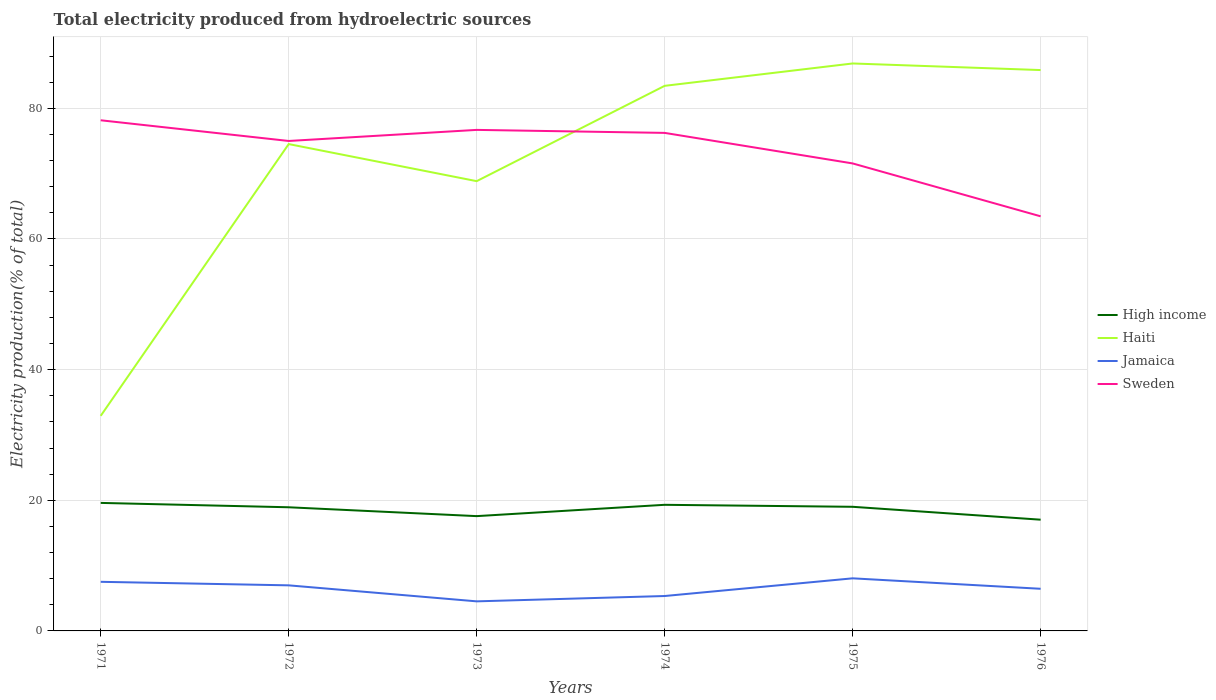How many different coloured lines are there?
Provide a succinct answer. 4. Does the line corresponding to High income intersect with the line corresponding to Jamaica?
Keep it short and to the point. No. Is the number of lines equal to the number of legend labels?
Your answer should be compact. Yes. Across all years, what is the maximum total electricity produced in Jamaica?
Offer a terse response. 4.53. In which year was the total electricity produced in High income maximum?
Ensure brevity in your answer.  1976. What is the total total electricity produced in Sweden in the graph?
Your answer should be compact. 3.44. What is the difference between the highest and the second highest total electricity produced in Sweden?
Offer a very short reply. 14.7. What is the difference between the highest and the lowest total electricity produced in Haiti?
Give a very brief answer. 4. How many years are there in the graph?
Give a very brief answer. 6. Does the graph contain any zero values?
Your answer should be compact. No. Where does the legend appear in the graph?
Make the answer very short. Center right. What is the title of the graph?
Keep it short and to the point. Total electricity produced from hydroelectric sources. Does "Middle income" appear as one of the legend labels in the graph?
Make the answer very short. No. What is the label or title of the Y-axis?
Ensure brevity in your answer.  Electricity production(% of total). What is the Electricity production(% of total) of High income in 1971?
Give a very brief answer. 19.6. What is the Electricity production(% of total) of Haiti in 1971?
Your answer should be compact. 32.93. What is the Electricity production(% of total) of Jamaica in 1971?
Keep it short and to the point. 7.52. What is the Electricity production(% of total) in Sweden in 1971?
Your response must be concise. 78.17. What is the Electricity production(% of total) of High income in 1972?
Ensure brevity in your answer.  18.93. What is the Electricity production(% of total) in Haiti in 1972?
Provide a short and direct response. 74.53. What is the Electricity production(% of total) in Jamaica in 1972?
Your answer should be compact. 6.98. What is the Electricity production(% of total) in Sweden in 1972?
Your answer should be very brief. 75. What is the Electricity production(% of total) in High income in 1973?
Offer a terse response. 17.57. What is the Electricity production(% of total) of Haiti in 1973?
Ensure brevity in your answer.  68.85. What is the Electricity production(% of total) of Jamaica in 1973?
Your answer should be compact. 4.53. What is the Electricity production(% of total) of Sweden in 1973?
Keep it short and to the point. 76.7. What is the Electricity production(% of total) of High income in 1974?
Provide a succinct answer. 19.31. What is the Electricity production(% of total) of Haiti in 1974?
Provide a short and direct response. 83.44. What is the Electricity production(% of total) in Jamaica in 1974?
Give a very brief answer. 5.34. What is the Electricity production(% of total) of Sweden in 1974?
Keep it short and to the point. 76.24. What is the Electricity production(% of total) in High income in 1975?
Keep it short and to the point. 19. What is the Electricity production(% of total) in Haiti in 1975?
Your answer should be compact. 86.87. What is the Electricity production(% of total) in Jamaica in 1975?
Offer a very short reply. 8.05. What is the Electricity production(% of total) in Sweden in 1975?
Your response must be concise. 71.57. What is the Electricity production(% of total) of High income in 1976?
Provide a succinct answer. 17.03. What is the Electricity production(% of total) in Haiti in 1976?
Make the answer very short. 85.86. What is the Electricity production(% of total) in Jamaica in 1976?
Provide a short and direct response. 6.45. What is the Electricity production(% of total) in Sweden in 1976?
Make the answer very short. 63.47. Across all years, what is the maximum Electricity production(% of total) of High income?
Make the answer very short. 19.6. Across all years, what is the maximum Electricity production(% of total) in Haiti?
Offer a terse response. 86.87. Across all years, what is the maximum Electricity production(% of total) in Jamaica?
Make the answer very short. 8.05. Across all years, what is the maximum Electricity production(% of total) in Sweden?
Your answer should be compact. 78.17. Across all years, what is the minimum Electricity production(% of total) in High income?
Your response must be concise. 17.03. Across all years, what is the minimum Electricity production(% of total) in Haiti?
Your answer should be very brief. 32.93. Across all years, what is the minimum Electricity production(% of total) of Jamaica?
Keep it short and to the point. 4.53. Across all years, what is the minimum Electricity production(% of total) in Sweden?
Your response must be concise. 63.47. What is the total Electricity production(% of total) in High income in the graph?
Your answer should be compact. 111.44. What is the total Electricity production(% of total) in Haiti in the graph?
Offer a very short reply. 432.48. What is the total Electricity production(% of total) of Jamaica in the graph?
Keep it short and to the point. 38.87. What is the total Electricity production(% of total) in Sweden in the graph?
Ensure brevity in your answer.  441.15. What is the difference between the Electricity production(% of total) in High income in 1971 and that in 1972?
Keep it short and to the point. 0.67. What is the difference between the Electricity production(% of total) in Haiti in 1971 and that in 1972?
Provide a succinct answer. -41.6. What is the difference between the Electricity production(% of total) in Jamaica in 1971 and that in 1972?
Ensure brevity in your answer.  0.54. What is the difference between the Electricity production(% of total) in Sweden in 1971 and that in 1972?
Offer a terse response. 3.17. What is the difference between the Electricity production(% of total) of High income in 1971 and that in 1973?
Make the answer very short. 2.02. What is the difference between the Electricity production(% of total) of Haiti in 1971 and that in 1973?
Make the answer very short. -35.93. What is the difference between the Electricity production(% of total) of Jamaica in 1971 and that in 1973?
Offer a very short reply. 2.99. What is the difference between the Electricity production(% of total) of Sweden in 1971 and that in 1973?
Provide a succinct answer. 1.47. What is the difference between the Electricity production(% of total) in High income in 1971 and that in 1974?
Keep it short and to the point. 0.29. What is the difference between the Electricity production(% of total) of Haiti in 1971 and that in 1974?
Provide a succinct answer. -50.52. What is the difference between the Electricity production(% of total) of Jamaica in 1971 and that in 1974?
Offer a very short reply. 2.17. What is the difference between the Electricity production(% of total) in Sweden in 1971 and that in 1974?
Keep it short and to the point. 1.93. What is the difference between the Electricity production(% of total) in High income in 1971 and that in 1975?
Your response must be concise. 0.6. What is the difference between the Electricity production(% of total) in Haiti in 1971 and that in 1975?
Offer a very short reply. -53.94. What is the difference between the Electricity production(% of total) in Jamaica in 1971 and that in 1975?
Keep it short and to the point. -0.53. What is the difference between the Electricity production(% of total) in Sweden in 1971 and that in 1975?
Offer a terse response. 6.61. What is the difference between the Electricity production(% of total) in High income in 1971 and that in 1976?
Your response must be concise. 2.57. What is the difference between the Electricity production(% of total) of Haiti in 1971 and that in 1976?
Your answer should be compact. -52.93. What is the difference between the Electricity production(% of total) of Jamaica in 1971 and that in 1976?
Ensure brevity in your answer.  1.07. What is the difference between the Electricity production(% of total) of Sweden in 1971 and that in 1976?
Offer a very short reply. 14.7. What is the difference between the Electricity production(% of total) of High income in 1972 and that in 1973?
Provide a short and direct response. 1.35. What is the difference between the Electricity production(% of total) of Haiti in 1972 and that in 1973?
Your answer should be compact. 5.68. What is the difference between the Electricity production(% of total) in Jamaica in 1972 and that in 1973?
Make the answer very short. 2.45. What is the difference between the Electricity production(% of total) in Sweden in 1972 and that in 1973?
Give a very brief answer. -1.7. What is the difference between the Electricity production(% of total) of High income in 1972 and that in 1974?
Your response must be concise. -0.38. What is the difference between the Electricity production(% of total) in Haiti in 1972 and that in 1974?
Your answer should be compact. -8.92. What is the difference between the Electricity production(% of total) in Jamaica in 1972 and that in 1974?
Your response must be concise. 1.63. What is the difference between the Electricity production(% of total) in Sweden in 1972 and that in 1974?
Offer a terse response. -1.24. What is the difference between the Electricity production(% of total) of High income in 1972 and that in 1975?
Make the answer very short. -0.07. What is the difference between the Electricity production(% of total) in Haiti in 1972 and that in 1975?
Ensure brevity in your answer.  -12.34. What is the difference between the Electricity production(% of total) of Jamaica in 1972 and that in 1975?
Keep it short and to the point. -1.07. What is the difference between the Electricity production(% of total) in Sweden in 1972 and that in 1975?
Your answer should be compact. 3.44. What is the difference between the Electricity production(% of total) in High income in 1972 and that in 1976?
Your answer should be very brief. 1.9. What is the difference between the Electricity production(% of total) of Haiti in 1972 and that in 1976?
Offer a terse response. -11.33. What is the difference between the Electricity production(% of total) in Jamaica in 1972 and that in 1976?
Make the answer very short. 0.53. What is the difference between the Electricity production(% of total) in Sweden in 1972 and that in 1976?
Offer a terse response. 11.54. What is the difference between the Electricity production(% of total) in High income in 1973 and that in 1974?
Offer a terse response. -1.73. What is the difference between the Electricity production(% of total) in Haiti in 1973 and that in 1974?
Your answer should be compact. -14.59. What is the difference between the Electricity production(% of total) of Jamaica in 1973 and that in 1974?
Provide a short and direct response. -0.82. What is the difference between the Electricity production(% of total) of Sweden in 1973 and that in 1974?
Make the answer very short. 0.46. What is the difference between the Electricity production(% of total) in High income in 1973 and that in 1975?
Offer a very short reply. -1.43. What is the difference between the Electricity production(% of total) in Haiti in 1973 and that in 1975?
Provide a short and direct response. -18.02. What is the difference between the Electricity production(% of total) in Jamaica in 1973 and that in 1975?
Make the answer very short. -3.52. What is the difference between the Electricity production(% of total) in Sweden in 1973 and that in 1975?
Offer a terse response. 5.13. What is the difference between the Electricity production(% of total) of High income in 1973 and that in 1976?
Offer a very short reply. 0.55. What is the difference between the Electricity production(% of total) in Haiti in 1973 and that in 1976?
Keep it short and to the point. -17.01. What is the difference between the Electricity production(% of total) of Jamaica in 1973 and that in 1976?
Provide a succinct answer. -1.92. What is the difference between the Electricity production(% of total) in Sweden in 1973 and that in 1976?
Ensure brevity in your answer.  13.23. What is the difference between the Electricity production(% of total) in High income in 1974 and that in 1975?
Give a very brief answer. 0.31. What is the difference between the Electricity production(% of total) of Haiti in 1974 and that in 1975?
Provide a short and direct response. -3.42. What is the difference between the Electricity production(% of total) of Jamaica in 1974 and that in 1975?
Keep it short and to the point. -2.71. What is the difference between the Electricity production(% of total) of Sweden in 1974 and that in 1975?
Provide a succinct answer. 4.68. What is the difference between the Electricity production(% of total) in High income in 1974 and that in 1976?
Offer a terse response. 2.28. What is the difference between the Electricity production(% of total) of Haiti in 1974 and that in 1976?
Keep it short and to the point. -2.41. What is the difference between the Electricity production(% of total) in Jamaica in 1974 and that in 1976?
Your answer should be very brief. -1.11. What is the difference between the Electricity production(% of total) of Sweden in 1974 and that in 1976?
Offer a terse response. 12.77. What is the difference between the Electricity production(% of total) in High income in 1975 and that in 1976?
Provide a short and direct response. 1.97. What is the difference between the Electricity production(% of total) of Sweden in 1975 and that in 1976?
Offer a very short reply. 8.1. What is the difference between the Electricity production(% of total) in High income in 1971 and the Electricity production(% of total) in Haiti in 1972?
Your answer should be very brief. -54.93. What is the difference between the Electricity production(% of total) in High income in 1971 and the Electricity production(% of total) in Jamaica in 1972?
Your answer should be very brief. 12.62. What is the difference between the Electricity production(% of total) in High income in 1971 and the Electricity production(% of total) in Sweden in 1972?
Offer a terse response. -55.41. What is the difference between the Electricity production(% of total) in Haiti in 1971 and the Electricity production(% of total) in Jamaica in 1972?
Give a very brief answer. 25.95. What is the difference between the Electricity production(% of total) of Haiti in 1971 and the Electricity production(% of total) of Sweden in 1972?
Offer a terse response. -42.08. What is the difference between the Electricity production(% of total) of Jamaica in 1971 and the Electricity production(% of total) of Sweden in 1972?
Your answer should be compact. -67.49. What is the difference between the Electricity production(% of total) in High income in 1971 and the Electricity production(% of total) in Haiti in 1973?
Provide a succinct answer. -49.26. What is the difference between the Electricity production(% of total) in High income in 1971 and the Electricity production(% of total) in Jamaica in 1973?
Provide a short and direct response. 15.07. What is the difference between the Electricity production(% of total) of High income in 1971 and the Electricity production(% of total) of Sweden in 1973?
Provide a succinct answer. -57.1. What is the difference between the Electricity production(% of total) in Haiti in 1971 and the Electricity production(% of total) in Jamaica in 1973?
Give a very brief answer. 28.4. What is the difference between the Electricity production(% of total) of Haiti in 1971 and the Electricity production(% of total) of Sweden in 1973?
Your response must be concise. -43.77. What is the difference between the Electricity production(% of total) of Jamaica in 1971 and the Electricity production(% of total) of Sweden in 1973?
Your response must be concise. -69.18. What is the difference between the Electricity production(% of total) in High income in 1971 and the Electricity production(% of total) in Haiti in 1974?
Ensure brevity in your answer.  -63.85. What is the difference between the Electricity production(% of total) of High income in 1971 and the Electricity production(% of total) of Jamaica in 1974?
Offer a terse response. 14.25. What is the difference between the Electricity production(% of total) in High income in 1971 and the Electricity production(% of total) in Sweden in 1974?
Keep it short and to the point. -56.64. What is the difference between the Electricity production(% of total) of Haiti in 1971 and the Electricity production(% of total) of Jamaica in 1974?
Your answer should be very brief. 27.58. What is the difference between the Electricity production(% of total) of Haiti in 1971 and the Electricity production(% of total) of Sweden in 1974?
Your answer should be compact. -43.31. What is the difference between the Electricity production(% of total) of Jamaica in 1971 and the Electricity production(% of total) of Sweden in 1974?
Ensure brevity in your answer.  -68.72. What is the difference between the Electricity production(% of total) in High income in 1971 and the Electricity production(% of total) in Haiti in 1975?
Offer a very short reply. -67.27. What is the difference between the Electricity production(% of total) of High income in 1971 and the Electricity production(% of total) of Jamaica in 1975?
Provide a succinct answer. 11.55. What is the difference between the Electricity production(% of total) in High income in 1971 and the Electricity production(% of total) in Sweden in 1975?
Give a very brief answer. -51.97. What is the difference between the Electricity production(% of total) of Haiti in 1971 and the Electricity production(% of total) of Jamaica in 1975?
Offer a very short reply. 24.88. What is the difference between the Electricity production(% of total) in Haiti in 1971 and the Electricity production(% of total) in Sweden in 1975?
Your response must be concise. -38.64. What is the difference between the Electricity production(% of total) in Jamaica in 1971 and the Electricity production(% of total) in Sweden in 1975?
Make the answer very short. -64.05. What is the difference between the Electricity production(% of total) of High income in 1971 and the Electricity production(% of total) of Haiti in 1976?
Your answer should be compact. -66.26. What is the difference between the Electricity production(% of total) in High income in 1971 and the Electricity production(% of total) in Jamaica in 1976?
Keep it short and to the point. 13.15. What is the difference between the Electricity production(% of total) of High income in 1971 and the Electricity production(% of total) of Sweden in 1976?
Provide a short and direct response. -43.87. What is the difference between the Electricity production(% of total) in Haiti in 1971 and the Electricity production(% of total) in Jamaica in 1976?
Ensure brevity in your answer.  26.48. What is the difference between the Electricity production(% of total) of Haiti in 1971 and the Electricity production(% of total) of Sweden in 1976?
Give a very brief answer. -30.54. What is the difference between the Electricity production(% of total) in Jamaica in 1971 and the Electricity production(% of total) in Sweden in 1976?
Your response must be concise. -55.95. What is the difference between the Electricity production(% of total) of High income in 1972 and the Electricity production(% of total) of Haiti in 1973?
Provide a succinct answer. -49.92. What is the difference between the Electricity production(% of total) in High income in 1972 and the Electricity production(% of total) in Jamaica in 1973?
Provide a succinct answer. 14.4. What is the difference between the Electricity production(% of total) in High income in 1972 and the Electricity production(% of total) in Sweden in 1973?
Provide a short and direct response. -57.77. What is the difference between the Electricity production(% of total) in Haiti in 1972 and the Electricity production(% of total) in Jamaica in 1973?
Your answer should be very brief. 70. What is the difference between the Electricity production(% of total) in Haiti in 1972 and the Electricity production(% of total) in Sweden in 1973?
Ensure brevity in your answer.  -2.17. What is the difference between the Electricity production(% of total) of Jamaica in 1972 and the Electricity production(% of total) of Sweden in 1973?
Offer a terse response. -69.72. What is the difference between the Electricity production(% of total) of High income in 1972 and the Electricity production(% of total) of Haiti in 1974?
Give a very brief answer. -64.51. What is the difference between the Electricity production(% of total) of High income in 1972 and the Electricity production(% of total) of Jamaica in 1974?
Ensure brevity in your answer.  13.59. What is the difference between the Electricity production(% of total) of High income in 1972 and the Electricity production(% of total) of Sweden in 1974?
Your answer should be very brief. -57.31. What is the difference between the Electricity production(% of total) in Haiti in 1972 and the Electricity production(% of total) in Jamaica in 1974?
Give a very brief answer. 69.18. What is the difference between the Electricity production(% of total) in Haiti in 1972 and the Electricity production(% of total) in Sweden in 1974?
Your answer should be compact. -1.71. What is the difference between the Electricity production(% of total) of Jamaica in 1972 and the Electricity production(% of total) of Sweden in 1974?
Keep it short and to the point. -69.26. What is the difference between the Electricity production(% of total) in High income in 1972 and the Electricity production(% of total) in Haiti in 1975?
Provide a succinct answer. -67.94. What is the difference between the Electricity production(% of total) of High income in 1972 and the Electricity production(% of total) of Jamaica in 1975?
Give a very brief answer. 10.88. What is the difference between the Electricity production(% of total) of High income in 1972 and the Electricity production(% of total) of Sweden in 1975?
Give a very brief answer. -52.64. What is the difference between the Electricity production(% of total) in Haiti in 1972 and the Electricity production(% of total) in Jamaica in 1975?
Keep it short and to the point. 66.48. What is the difference between the Electricity production(% of total) in Haiti in 1972 and the Electricity production(% of total) in Sweden in 1975?
Give a very brief answer. 2.96. What is the difference between the Electricity production(% of total) of Jamaica in 1972 and the Electricity production(% of total) of Sweden in 1975?
Make the answer very short. -64.59. What is the difference between the Electricity production(% of total) of High income in 1972 and the Electricity production(% of total) of Haiti in 1976?
Your answer should be very brief. -66.93. What is the difference between the Electricity production(% of total) of High income in 1972 and the Electricity production(% of total) of Jamaica in 1976?
Provide a succinct answer. 12.48. What is the difference between the Electricity production(% of total) in High income in 1972 and the Electricity production(% of total) in Sweden in 1976?
Your answer should be very brief. -44.54. What is the difference between the Electricity production(% of total) in Haiti in 1972 and the Electricity production(% of total) in Jamaica in 1976?
Offer a terse response. 68.08. What is the difference between the Electricity production(% of total) in Haiti in 1972 and the Electricity production(% of total) in Sweden in 1976?
Make the answer very short. 11.06. What is the difference between the Electricity production(% of total) of Jamaica in 1972 and the Electricity production(% of total) of Sweden in 1976?
Offer a very short reply. -56.49. What is the difference between the Electricity production(% of total) in High income in 1973 and the Electricity production(% of total) in Haiti in 1974?
Ensure brevity in your answer.  -65.87. What is the difference between the Electricity production(% of total) of High income in 1973 and the Electricity production(% of total) of Jamaica in 1974?
Keep it short and to the point. 12.23. What is the difference between the Electricity production(% of total) of High income in 1973 and the Electricity production(% of total) of Sweden in 1974?
Ensure brevity in your answer.  -58.67. What is the difference between the Electricity production(% of total) in Haiti in 1973 and the Electricity production(% of total) in Jamaica in 1974?
Your response must be concise. 63.51. What is the difference between the Electricity production(% of total) in Haiti in 1973 and the Electricity production(% of total) in Sweden in 1974?
Provide a short and direct response. -7.39. What is the difference between the Electricity production(% of total) of Jamaica in 1973 and the Electricity production(% of total) of Sweden in 1974?
Your answer should be very brief. -71.71. What is the difference between the Electricity production(% of total) of High income in 1973 and the Electricity production(% of total) of Haiti in 1975?
Offer a terse response. -69.29. What is the difference between the Electricity production(% of total) in High income in 1973 and the Electricity production(% of total) in Jamaica in 1975?
Your answer should be compact. 9.52. What is the difference between the Electricity production(% of total) of High income in 1973 and the Electricity production(% of total) of Sweden in 1975?
Your answer should be compact. -53.99. What is the difference between the Electricity production(% of total) of Haiti in 1973 and the Electricity production(% of total) of Jamaica in 1975?
Ensure brevity in your answer.  60.8. What is the difference between the Electricity production(% of total) in Haiti in 1973 and the Electricity production(% of total) in Sweden in 1975?
Provide a short and direct response. -2.71. What is the difference between the Electricity production(% of total) of Jamaica in 1973 and the Electricity production(% of total) of Sweden in 1975?
Your answer should be compact. -67.04. What is the difference between the Electricity production(% of total) of High income in 1973 and the Electricity production(% of total) of Haiti in 1976?
Ensure brevity in your answer.  -68.28. What is the difference between the Electricity production(% of total) in High income in 1973 and the Electricity production(% of total) in Jamaica in 1976?
Your response must be concise. 11.12. What is the difference between the Electricity production(% of total) in High income in 1973 and the Electricity production(% of total) in Sweden in 1976?
Provide a short and direct response. -45.89. What is the difference between the Electricity production(% of total) of Haiti in 1973 and the Electricity production(% of total) of Jamaica in 1976?
Make the answer very short. 62.4. What is the difference between the Electricity production(% of total) of Haiti in 1973 and the Electricity production(% of total) of Sweden in 1976?
Provide a succinct answer. 5.38. What is the difference between the Electricity production(% of total) of Jamaica in 1973 and the Electricity production(% of total) of Sweden in 1976?
Provide a short and direct response. -58.94. What is the difference between the Electricity production(% of total) in High income in 1974 and the Electricity production(% of total) in Haiti in 1975?
Your response must be concise. -67.56. What is the difference between the Electricity production(% of total) of High income in 1974 and the Electricity production(% of total) of Jamaica in 1975?
Provide a succinct answer. 11.25. What is the difference between the Electricity production(% of total) in High income in 1974 and the Electricity production(% of total) in Sweden in 1975?
Keep it short and to the point. -52.26. What is the difference between the Electricity production(% of total) of Haiti in 1974 and the Electricity production(% of total) of Jamaica in 1975?
Offer a terse response. 75.39. What is the difference between the Electricity production(% of total) of Haiti in 1974 and the Electricity production(% of total) of Sweden in 1975?
Offer a very short reply. 11.88. What is the difference between the Electricity production(% of total) of Jamaica in 1974 and the Electricity production(% of total) of Sweden in 1975?
Your answer should be compact. -66.22. What is the difference between the Electricity production(% of total) in High income in 1974 and the Electricity production(% of total) in Haiti in 1976?
Provide a succinct answer. -66.55. What is the difference between the Electricity production(% of total) in High income in 1974 and the Electricity production(% of total) in Jamaica in 1976?
Ensure brevity in your answer.  12.85. What is the difference between the Electricity production(% of total) in High income in 1974 and the Electricity production(% of total) in Sweden in 1976?
Give a very brief answer. -44.16. What is the difference between the Electricity production(% of total) in Haiti in 1974 and the Electricity production(% of total) in Jamaica in 1976?
Offer a very short reply. 76.99. What is the difference between the Electricity production(% of total) of Haiti in 1974 and the Electricity production(% of total) of Sweden in 1976?
Offer a terse response. 19.97. What is the difference between the Electricity production(% of total) in Jamaica in 1974 and the Electricity production(% of total) in Sweden in 1976?
Offer a very short reply. -58.12. What is the difference between the Electricity production(% of total) of High income in 1975 and the Electricity production(% of total) of Haiti in 1976?
Provide a short and direct response. -66.86. What is the difference between the Electricity production(% of total) in High income in 1975 and the Electricity production(% of total) in Jamaica in 1976?
Provide a short and direct response. 12.55. What is the difference between the Electricity production(% of total) in High income in 1975 and the Electricity production(% of total) in Sweden in 1976?
Provide a succinct answer. -44.47. What is the difference between the Electricity production(% of total) in Haiti in 1975 and the Electricity production(% of total) in Jamaica in 1976?
Give a very brief answer. 80.42. What is the difference between the Electricity production(% of total) of Haiti in 1975 and the Electricity production(% of total) of Sweden in 1976?
Offer a terse response. 23.4. What is the difference between the Electricity production(% of total) of Jamaica in 1975 and the Electricity production(% of total) of Sweden in 1976?
Give a very brief answer. -55.42. What is the average Electricity production(% of total) of High income per year?
Offer a terse response. 18.57. What is the average Electricity production(% of total) of Haiti per year?
Ensure brevity in your answer.  72.08. What is the average Electricity production(% of total) of Jamaica per year?
Your response must be concise. 6.48. What is the average Electricity production(% of total) of Sweden per year?
Ensure brevity in your answer.  73.53. In the year 1971, what is the difference between the Electricity production(% of total) of High income and Electricity production(% of total) of Haiti?
Provide a short and direct response. -13.33. In the year 1971, what is the difference between the Electricity production(% of total) of High income and Electricity production(% of total) of Jamaica?
Make the answer very short. 12.08. In the year 1971, what is the difference between the Electricity production(% of total) in High income and Electricity production(% of total) in Sweden?
Make the answer very short. -58.58. In the year 1971, what is the difference between the Electricity production(% of total) in Haiti and Electricity production(% of total) in Jamaica?
Your answer should be compact. 25.41. In the year 1971, what is the difference between the Electricity production(% of total) of Haiti and Electricity production(% of total) of Sweden?
Provide a short and direct response. -45.25. In the year 1971, what is the difference between the Electricity production(% of total) in Jamaica and Electricity production(% of total) in Sweden?
Offer a very short reply. -70.66. In the year 1972, what is the difference between the Electricity production(% of total) of High income and Electricity production(% of total) of Haiti?
Give a very brief answer. -55.6. In the year 1972, what is the difference between the Electricity production(% of total) in High income and Electricity production(% of total) in Jamaica?
Offer a terse response. 11.95. In the year 1972, what is the difference between the Electricity production(% of total) in High income and Electricity production(% of total) in Sweden?
Ensure brevity in your answer.  -56.08. In the year 1972, what is the difference between the Electricity production(% of total) in Haiti and Electricity production(% of total) in Jamaica?
Give a very brief answer. 67.55. In the year 1972, what is the difference between the Electricity production(% of total) of Haiti and Electricity production(% of total) of Sweden?
Offer a very short reply. -0.48. In the year 1972, what is the difference between the Electricity production(% of total) of Jamaica and Electricity production(% of total) of Sweden?
Your answer should be very brief. -68.03. In the year 1973, what is the difference between the Electricity production(% of total) of High income and Electricity production(% of total) of Haiti?
Offer a very short reply. -51.28. In the year 1973, what is the difference between the Electricity production(% of total) of High income and Electricity production(% of total) of Jamaica?
Your response must be concise. 13.05. In the year 1973, what is the difference between the Electricity production(% of total) in High income and Electricity production(% of total) in Sweden?
Ensure brevity in your answer.  -59.13. In the year 1973, what is the difference between the Electricity production(% of total) of Haiti and Electricity production(% of total) of Jamaica?
Your response must be concise. 64.33. In the year 1973, what is the difference between the Electricity production(% of total) of Haiti and Electricity production(% of total) of Sweden?
Offer a terse response. -7.85. In the year 1973, what is the difference between the Electricity production(% of total) in Jamaica and Electricity production(% of total) in Sweden?
Keep it short and to the point. -72.17. In the year 1974, what is the difference between the Electricity production(% of total) of High income and Electricity production(% of total) of Haiti?
Your answer should be very brief. -64.14. In the year 1974, what is the difference between the Electricity production(% of total) of High income and Electricity production(% of total) of Jamaica?
Your response must be concise. 13.96. In the year 1974, what is the difference between the Electricity production(% of total) of High income and Electricity production(% of total) of Sweden?
Your answer should be compact. -56.94. In the year 1974, what is the difference between the Electricity production(% of total) of Haiti and Electricity production(% of total) of Jamaica?
Give a very brief answer. 78.1. In the year 1974, what is the difference between the Electricity production(% of total) of Haiti and Electricity production(% of total) of Sweden?
Your answer should be very brief. 7.2. In the year 1974, what is the difference between the Electricity production(% of total) in Jamaica and Electricity production(% of total) in Sweden?
Give a very brief answer. -70.9. In the year 1975, what is the difference between the Electricity production(% of total) in High income and Electricity production(% of total) in Haiti?
Your answer should be compact. -67.87. In the year 1975, what is the difference between the Electricity production(% of total) in High income and Electricity production(% of total) in Jamaica?
Give a very brief answer. 10.95. In the year 1975, what is the difference between the Electricity production(% of total) in High income and Electricity production(% of total) in Sweden?
Your answer should be very brief. -52.57. In the year 1975, what is the difference between the Electricity production(% of total) in Haiti and Electricity production(% of total) in Jamaica?
Your answer should be very brief. 78.82. In the year 1975, what is the difference between the Electricity production(% of total) in Haiti and Electricity production(% of total) in Sweden?
Provide a succinct answer. 15.3. In the year 1975, what is the difference between the Electricity production(% of total) of Jamaica and Electricity production(% of total) of Sweden?
Your answer should be compact. -63.51. In the year 1976, what is the difference between the Electricity production(% of total) of High income and Electricity production(% of total) of Haiti?
Give a very brief answer. -68.83. In the year 1976, what is the difference between the Electricity production(% of total) in High income and Electricity production(% of total) in Jamaica?
Offer a terse response. 10.58. In the year 1976, what is the difference between the Electricity production(% of total) of High income and Electricity production(% of total) of Sweden?
Your answer should be compact. -46.44. In the year 1976, what is the difference between the Electricity production(% of total) of Haiti and Electricity production(% of total) of Jamaica?
Provide a short and direct response. 79.41. In the year 1976, what is the difference between the Electricity production(% of total) in Haiti and Electricity production(% of total) in Sweden?
Offer a very short reply. 22.39. In the year 1976, what is the difference between the Electricity production(% of total) of Jamaica and Electricity production(% of total) of Sweden?
Your response must be concise. -57.02. What is the ratio of the Electricity production(% of total) of High income in 1971 to that in 1972?
Your answer should be compact. 1.04. What is the ratio of the Electricity production(% of total) in Haiti in 1971 to that in 1972?
Give a very brief answer. 0.44. What is the ratio of the Electricity production(% of total) in Jamaica in 1971 to that in 1972?
Your answer should be very brief. 1.08. What is the ratio of the Electricity production(% of total) in Sweden in 1971 to that in 1972?
Your answer should be compact. 1.04. What is the ratio of the Electricity production(% of total) of High income in 1971 to that in 1973?
Your response must be concise. 1.12. What is the ratio of the Electricity production(% of total) in Haiti in 1971 to that in 1973?
Make the answer very short. 0.48. What is the ratio of the Electricity production(% of total) of Jamaica in 1971 to that in 1973?
Offer a terse response. 1.66. What is the ratio of the Electricity production(% of total) of Sweden in 1971 to that in 1973?
Offer a terse response. 1.02. What is the ratio of the Electricity production(% of total) of High income in 1971 to that in 1974?
Offer a very short reply. 1.02. What is the ratio of the Electricity production(% of total) of Haiti in 1971 to that in 1974?
Give a very brief answer. 0.39. What is the ratio of the Electricity production(% of total) in Jamaica in 1971 to that in 1974?
Keep it short and to the point. 1.41. What is the ratio of the Electricity production(% of total) in Sweden in 1971 to that in 1974?
Ensure brevity in your answer.  1.03. What is the ratio of the Electricity production(% of total) of High income in 1971 to that in 1975?
Provide a short and direct response. 1.03. What is the ratio of the Electricity production(% of total) in Haiti in 1971 to that in 1975?
Give a very brief answer. 0.38. What is the ratio of the Electricity production(% of total) of Jamaica in 1971 to that in 1975?
Ensure brevity in your answer.  0.93. What is the ratio of the Electricity production(% of total) of Sweden in 1971 to that in 1975?
Offer a terse response. 1.09. What is the ratio of the Electricity production(% of total) in High income in 1971 to that in 1976?
Give a very brief answer. 1.15. What is the ratio of the Electricity production(% of total) in Haiti in 1971 to that in 1976?
Keep it short and to the point. 0.38. What is the ratio of the Electricity production(% of total) in Jamaica in 1971 to that in 1976?
Your answer should be very brief. 1.17. What is the ratio of the Electricity production(% of total) of Sweden in 1971 to that in 1976?
Provide a short and direct response. 1.23. What is the ratio of the Electricity production(% of total) of High income in 1972 to that in 1973?
Make the answer very short. 1.08. What is the ratio of the Electricity production(% of total) in Haiti in 1972 to that in 1973?
Provide a short and direct response. 1.08. What is the ratio of the Electricity production(% of total) in Jamaica in 1972 to that in 1973?
Provide a short and direct response. 1.54. What is the ratio of the Electricity production(% of total) in Sweden in 1972 to that in 1973?
Keep it short and to the point. 0.98. What is the ratio of the Electricity production(% of total) in High income in 1972 to that in 1974?
Give a very brief answer. 0.98. What is the ratio of the Electricity production(% of total) in Haiti in 1972 to that in 1974?
Provide a short and direct response. 0.89. What is the ratio of the Electricity production(% of total) in Jamaica in 1972 to that in 1974?
Give a very brief answer. 1.31. What is the ratio of the Electricity production(% of total) in Sweden in 1972 to that in 1974?
Your answer should be compact. 0.98. What is the ratio of the Electricity production(% of total) of High income in 1972 to that in 1975?
Keep it short and to the point. 1. What is the ratio of the Electricity production(% of total) in Haiti in 1972 to that in 1975?
Your response must be concise. 0.86. What is the ratio of the Electricity production(% of total) in Jamaica in 1972 to that in 1975?
Offer a terse response. 0.87. What is the ratio of the Electricity production(% of total) of Sweden in 1972 to that in 1975?
Provide a succinct answer. 1.05. What is the ratio of the Electricity production(% of total) in High income in 1972 to that in 1976?
Make the answer very short. 1.11. What is the ratio of the Electricity production(% of total) in Haiti in 1972 to that in 1976?
Offer a terse response. 0.87. What is the ratio of the Electricity production(% of total) of Jamaica in 1972 to that in 1976?
Your response must be concise. 1.08. What is the ratio of the Electricity production(% of total) of Sweden in 1972 to that in 1976?
Your answer should be compact. 1.18. What is the ratio of the Electricity production(% of total) of High income in 1973 to that in 1974?
Your answer should be compact. 0.91. What is the ratio of the Electricity production(% of total) in Haiti in 1973 to that in 1974?
Keep it short and to the point. 0.83. What is the ratio of the Electricity production(% of total) of Jamaica in 1973 to that in 1974?
Ensure brevity in your answer.  0.85. What is the ratio of the Electricity production(% of total) of Sweden in 1973 to that in 1974?
Provide a succinct answer. 1.01. What is the ratio of the Electricity production(% of total) in High income in 1973 to that in 1975?
Offer a very short reply. 0.92. What is the ratio of the Electricity production(% of total) in Haiti in 1973 to that in 1975?
Offer a terse response. 0.79. What is the ratio of the Electricity production(% of total) of Jamaica in 1973 to that in 1975?
Offer a very short reply. 0.56. What is the ratio of the Electricity production(% of total) in Sweden in 1973 to that in 1975?
Your response must be concise. 1.07. What is the ratio of the Electricity production(% of total) in High income in 1973 to that in 1976?
Your answer should be very brief. 1.03. What is the ratio of the Electricity production(% of total) in Haiti in 1973 to that in 1976?
Your answer should be compact. 0.8. What is the ratio of the Electricity production(% of total) in Jamaica in 1973 to that in 1976?
Give a very brief answer. 0.7. What is the ratio of the Electricity production(% of total) of Sweden in 1973 to that in 1976?
Your answer should be compact. 1.21. What is the ratio of the Electricity production(% of total) in High income in 1974 to that in 1975?
Your answer should be compact. 1.02. What is the ratio of the Electricity production(% of total) in Haiti in 1974 to that in 1975?
Offer a very short reply. 0.96. What is the ratio of the Electricity production(% of total) of Jamaica in 1974 to that in 1975?
Your answer should be very brief. 0.66. What is the ratio of the Electricity production(% of total) of Sweden in 1974 to that in 1975?
Your answer should be compact. 1.07. What is the ratio of the Electricity production(% of total) of High income in 1974 to that in 1976?
Ensure brevity in your answer.  1.13. What is the ratio of the Electricity production(% of total) in Haiti in 1974 to that in 1976?
Ensure brevity in your answer.  0.97. What is the ratio of the Electricity production(% of total) in Jamaica in 1974 to that in 1976?
Provide a short and direct response. 0.83. What is the ratio of the Electricity production(% of total) in Sweden in 1974 to that in 1976?
Ensure brevity in your answer.  1.2. What is the ratio of the Electricity production(% of total) of High income in 1975 to that in 1976?
Offer a very short reply. 1.12. What is the ratio of the Electricity production(% of total) of Haiti in 1975 to that in 1976?
Your answer should be very brief. 1.01. What is the ratio of the Electricity production(% of total) in Jamaica in 1975 to that in 1976?
Your response must be concise. 1.25. What is the ratio of the Electricity production(% of total) in Sweden in 1975 to that in 1976?
Your answer should be very brief. 1.13. What is the difference between the highest and the second highest Electricity production(% of total) of High income?
Ensure brevity in your answer.  0.29. What is the difference between the highest and the second highest Electricity production(% of total) in Jamaica?
Your response must be concise. 0.53. What is the difference between the highest and the second highest Electricity production(% of total) in Sweden?
Provide a succinct answer. 1.47. What is the difference between the highest and the lowest Electricity production(% of total) of High income?
Provide a short and direct response. 2.57. What is the difference between the highest and the lowest Electricity production(% of total) of Haiti?
Provide a succinct answer. 53.94. What is the difference between the highest and the lowest Electricity production(% of total) in Jamaica?
Keep it short and to the point. 3.52. What is the difference between the highest and the lowest Electricity production(% of total) of Sweden?
Provide a succinct answer. 14.7. 